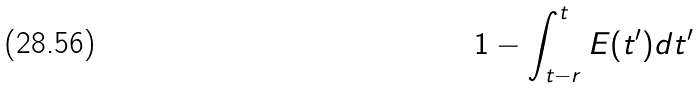<formula> <loc_0><loc_0><loc_500><loc_500>1 - \int _ { t - r } ^ { t } E ( t ^ { \prime } ) d t ^ { \prime }</formula> 